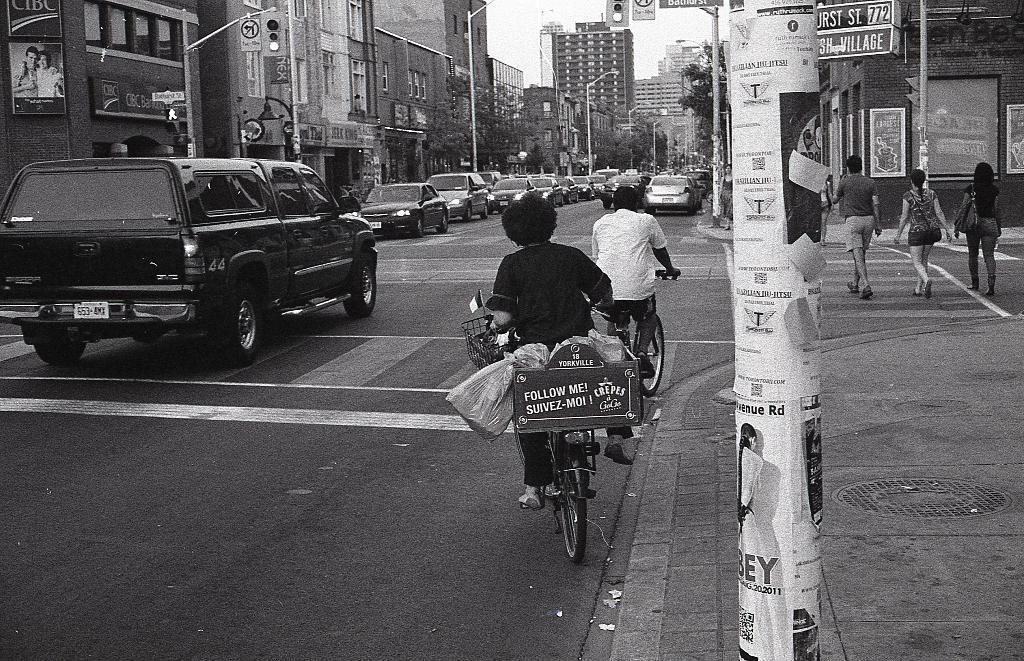In one or two sentences, can you explain what this image depicts? This picture show this picture shows two people riding bicycle and we see few cars parked on the road and we see few people walking on the road and we see few buildings and a couple of trees 